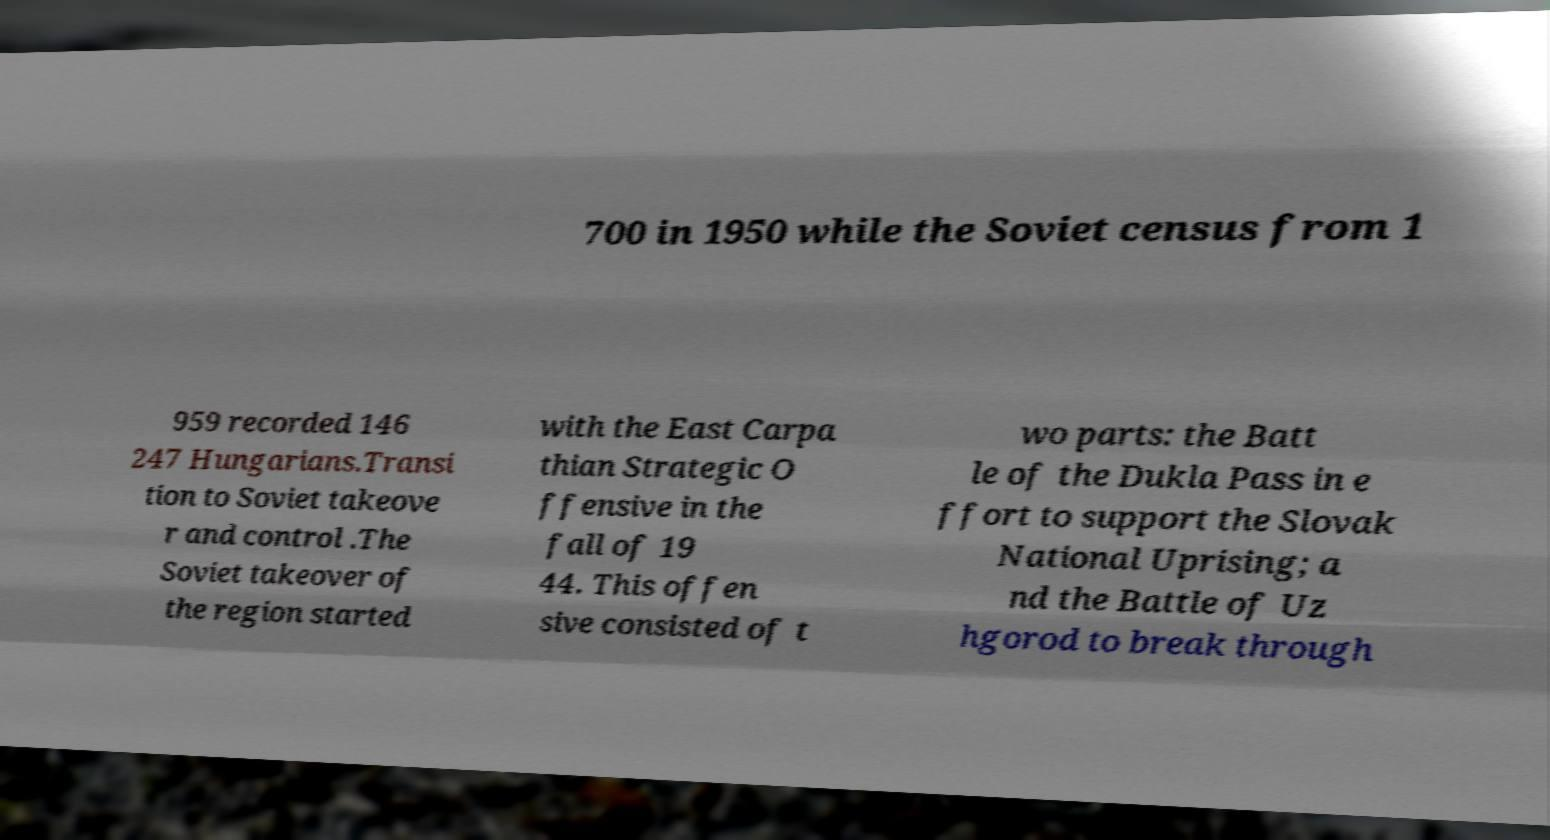Could you assist in decoding the text presented in this image and type it out clearly? 700 in 1950 while the Soviet census from 1 959 recorded 146 247 Hungarians.Transi tion to Soviet takeove r and control .The Soviet takeover of the region started with the East Carpa thian Strategic O ffensive in the fall of 19 44. This offen sive consisted of t wo parts: the Batt le of the Dukla Pass in e ffort to support the Slovak National Uprising; a nd the Battle of Uz hgorod to break through 